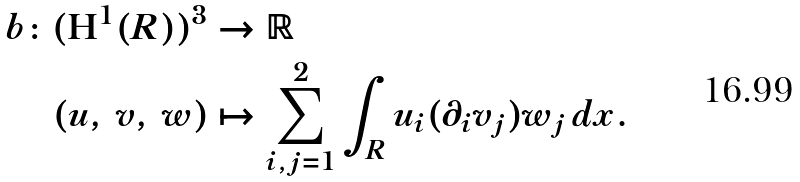<formula> <loc_0><loc_0><loc_500><loc_500>b \colon ( \mathbf H ^ { 1 } ( R ) ) ^ { 3 } & \to \mathbb { R } \\ ( u , \, v , \, w ) & \mapsto \sum _ { i , j = 1 } ^ { 2 } \int _ { R } u _ { i } ( \partial _ { i } v _ { j } ) w _ { j } \, d x . \</formula> 